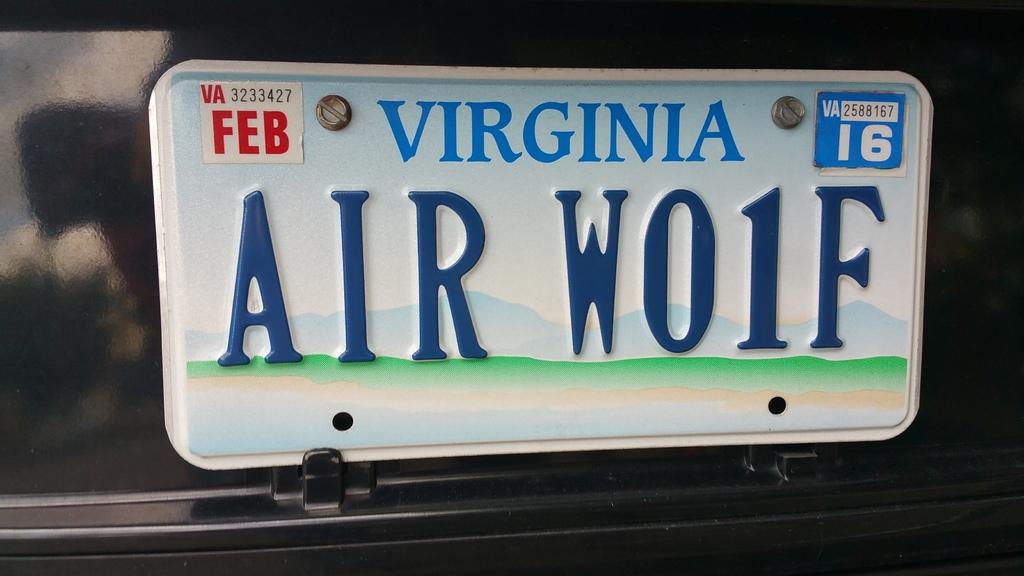What year will the plate expire?
Your answer should be compact. 2016. 